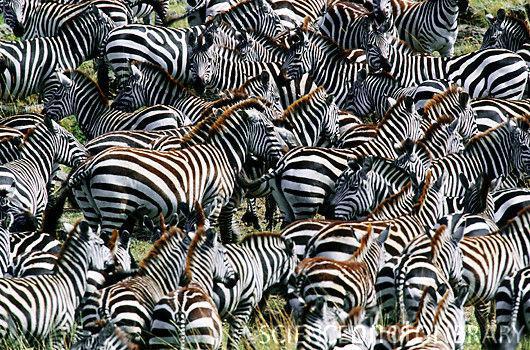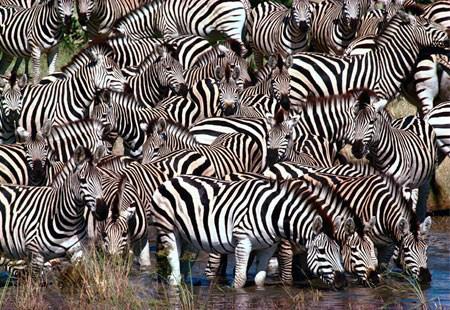The first image is the image on the left, the second image is the image on the right. Evaluate the accuracy of this statement regarding the images: "The left image includes a row of leftward-facing zebras standing in water and bending their necks to drink.". Is it true? Answer yes or no. No. The first image is the image on the left, the second image is the image on the right. For the images displayed, is the sentence "Some of the zebras are standing in water in one of the images." factually correct? Answer yes or no. Yes. 